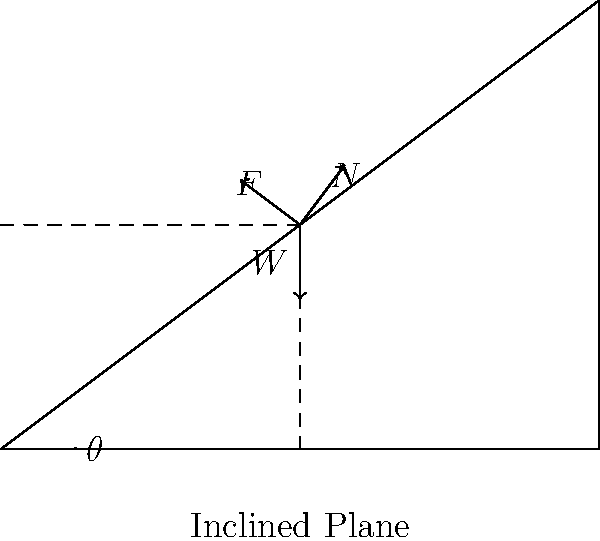A person is standing on an inclined plane that makes an angle $\theta$ with the horizontal. If the person's weight is $W$, what is the magnitude of the normal force $N$ acting on the person? To find the magnitude of the normal force $N$, we need to consider the forces acting on the person and their components perpendicular to the inclined plane. Let's break this down step-by-step:

1. Identify the forces:
   - Weight ($W$): Always acts vertically downward
   - Normal force ($N$): Acts perpendicular to the inclined plane
   - Friction force ($F$): Acts parallel to the inclined plane (not needed for this calculation)

2. Resolve the weight force into components:
   - Component parallel to the plane: $W \sin\theta$
   - Component perpendicular to the plane: $W \cos\theta$

3. Consider the equilibrium condition:
   For the person to remain stationary, the forces perpendicular to the plane must balance out.

4. Set up the equation:
   $N = W \cos\theta$

5. This equation gives us the magnitude of the normal force in terms of the person's weight and the angle of inclination.

Therefore, the magnitude of the normal force $N$ acting on the person is $W \cos\theta$.
Answer: $N = W \cos\theta$ 